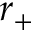<formula> <loc_0><loc_0><loc_500><loc_500>r _ { + }</formula> 